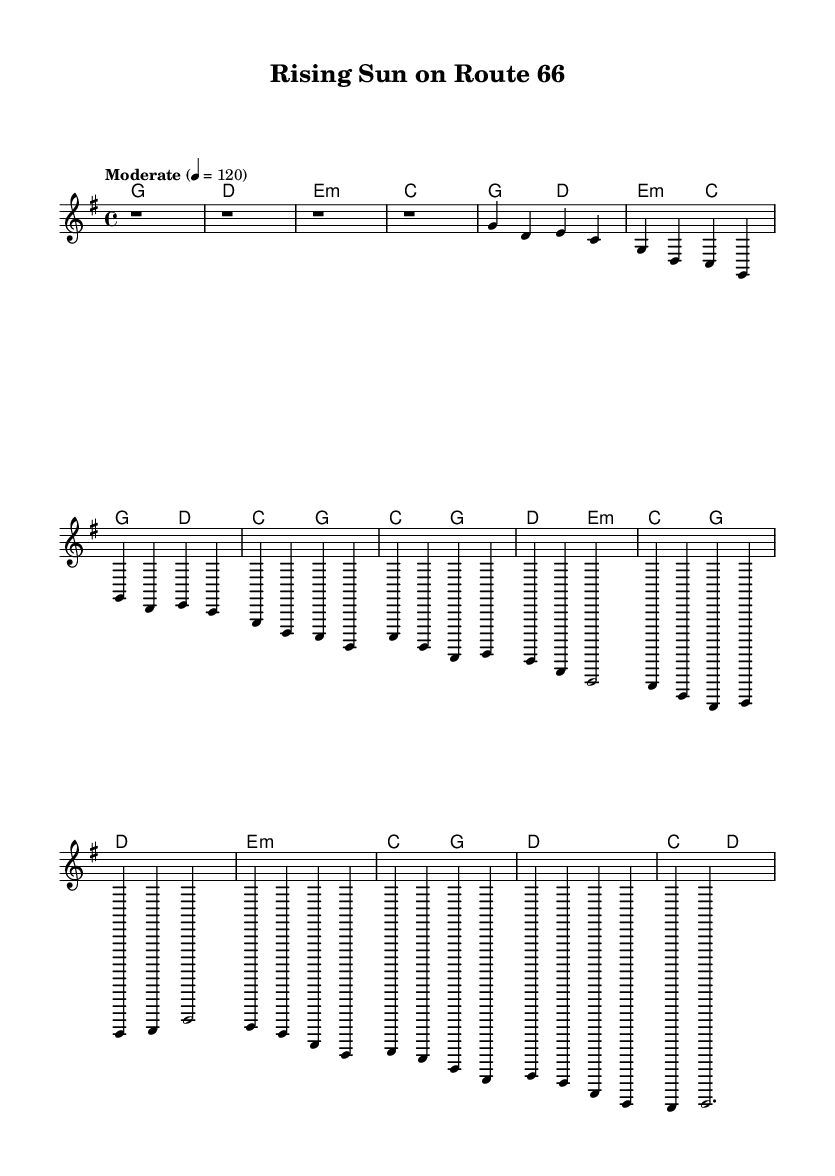What is the key signature of this music? The key signature indicates the number of sharps or flats in a piece. In this sheet music, the key signature is G major, which has one sharp (F#).
Answer: G major What is the time signature of the piece? The time signature shows how many beats are in each measure and what note value is equivalent to one beat. Here, the time signature is 4/4, indicating there are four beats per measure and the quarter note gets one beat.
Answer: 4/4 What is the tempo marking for the piece? The tempo marking provides a guideline for the speed of the piece. In this sheet music, it states "Moderate" with a tempo of 120 beats per minute, indicating a moderately paced song.
Answer: Moderate How many measures are in the chorus section? To determine the number of measures in the chorus, we can count from the beginning of the chorus to its end. The chorus features four measures before concluding.
Answer: 4 What is the relationship between the verse and the chorus chords? The chords in the verse and chorus share the same key and utilize similar chord changes, creating a coherent musical structure typical in country rock songs. This allows for transitions that maintain the song's overall character.
Answer: Similar Which section contains a bridge, and how many measures does it have? The bridge is a distinct section that provides contrast. In this sheet music, the bridge consists of four measures, specifically highlighting a change in harmony and melody from the preceding verse.
Answer: 4 What stylistic element is evident in the song's structure? The repetition of the verse and chorus is a common feature in country rock music, which aids in creating memorable hooks and engaging listeners through familiar musical patterns. This is evident from their respective sections—both the verse and chorus repeat musical phrases.
Answer: Repetition 